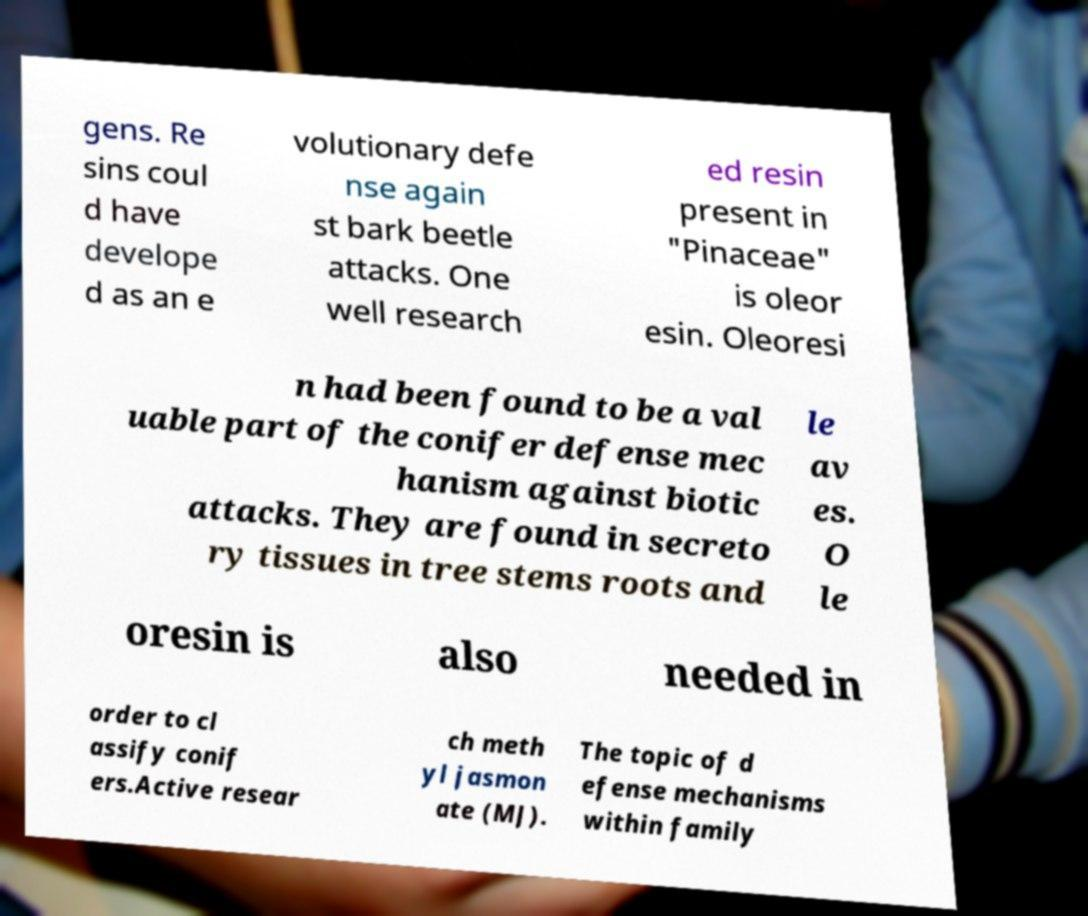Could you assist in decoding the text presented in this image and type it out clearly? gens. Re sins coul d have develope d as an e volutionary defe nse again st bark beetle attacks. One well research ed resin present in "Pinaceae" is oleor esin. Oleoresi n had been found to be a val uable part of the conifer defense mec hanism against biotic attacks. They are found in secreto ry tissues in tree stems roots and le av es. O le oresin is also needed in order to cl assify conif ers.Active resear ch meth yl jasmon ate (MJ). The topic of d efense mechanisms within family 